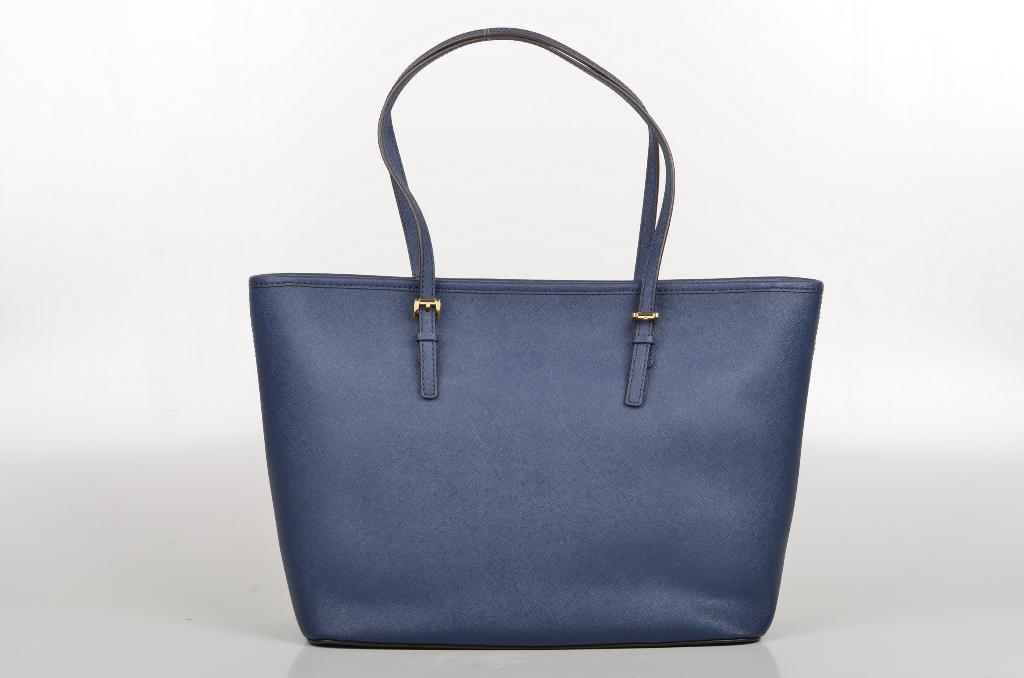What object can be seen in the image? There is a bag in the image. What is the color of the bag? The bag is blue in color. Does the bag have any specific features? Yes, the bag has a handle. What role does the brother play in the army in the image? There is no brother or army present in the image; it only features a blue bag with a handle. 